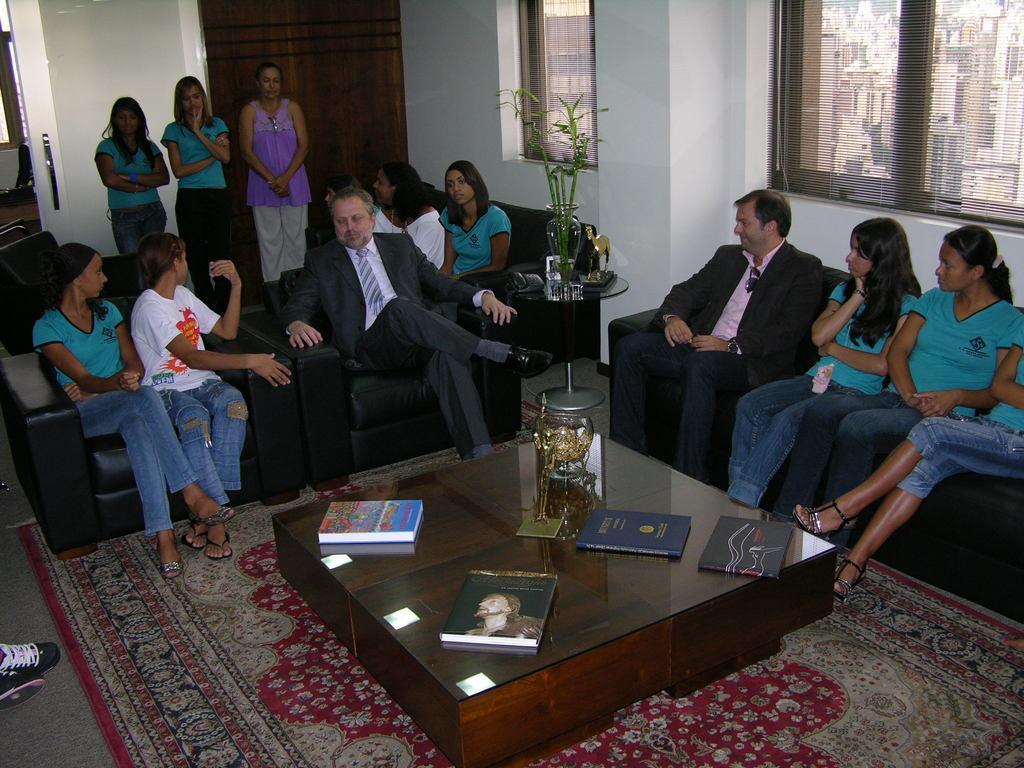Please provide a concise description of this image. In the given image we can see sofas and there are people sitting on sofa. This is a carpet which is in cream and red color. There is a table, on the table we have four books. This is a plant and a window. 